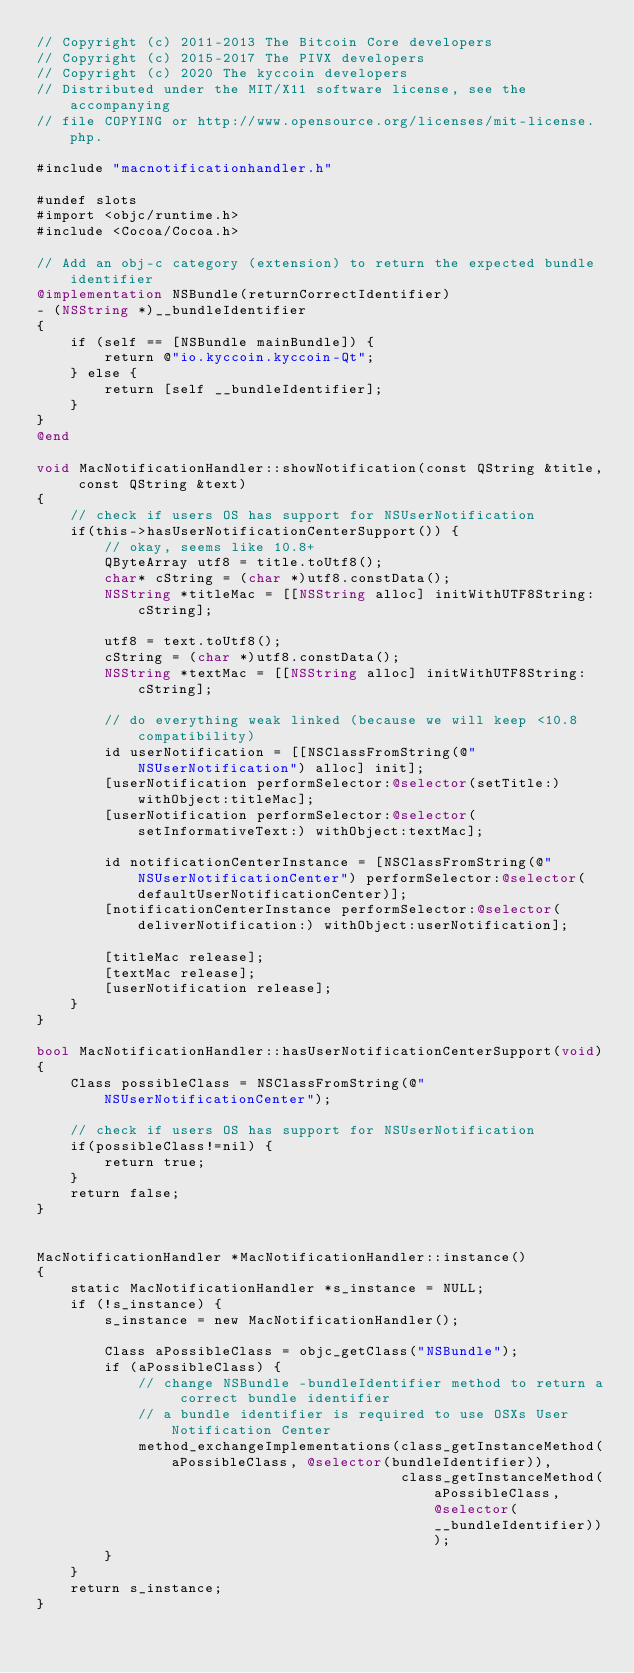Convert code to text. <code><loc_0><loc_0><loc_500><loc_500><_ObjectiveC_>// Copyright (c) 2011-2013 The Bitcoin Core developers
// Copyright (c) 2015-2017 The PIVX developers
// Copyright (c) 2020 The kyccoin developers
// Distributed under the MIT/X11 software license, see the accompanying
// file COPYING or http://www.opensource.org/licenses/mit-license.php.

#include "macnotificationhandler.h"

#undef slots
#import <objc/runtime.h>
#include <Cocoa/Cocoa.h>

// Add an obj-c category (extension) to return the expected bundle identifier
@implementation NSBundle(returnCorrectIdentifier)
- (NSString *)__bundleIdentifier
{
    if (self == [NSBundle mainBundle]) {
        return @"io.kyccoin.kyccoin-Qt";
    } else {
        return [self __bundleIdentifier];
    }
}
@end

void MacNotificationHandler::showNotification(const QString &title, const QString &text)
{
    // check if users OS has support for NSUserNotification
    if(this->hasUserNotificationCenterSupport()) {
        // okay, seems like 10.8+
        QByteArray utf8 = title.toUtf8();
        char* cString = (char *)utf8.constData();
        NSString *titleMac = [[NSString alloc] initWithUTF8String:cString];

        utf8 = text.toUtf8();
        cString = (char *)utf8.constData();
        NSString *textMac = [[NSString alloc] initWithUTF8String:cString];

        // do everything weak linked (because we will keep <10.8 compatibility)
        id userNotification = [[NSClassFromString(@"NSUserNotification") alloc] init];
        [userNotification performSelector:@selector(setTitle:) withObject:titleMac];
        [userNotification performSelector:@selector(setInformativeText:) withObject:textMac];

        id notificationCenterInstance = [NSClassFromString(@"NSUserNotificationCenter") performSelector:@selector(defaultUserNotificationCenter)];
        [notificationCenterInstance performSelector:@selector(deliverNotification:) withObject:userNotification];

        [titleMac release];
        [textMac release];
        [userNotification release];
    }
}

bool MacNotificationHandler::hasUserNotificationCenterSupport(void)
{
    Class possibleClass = NSClassFromString(@"NSUserNotificationCenter");

    // check if users OS has support for NSUserNotification
    if(possibleClass!=nil) {
        return true;
    }
    return false;
}


MacNotificationHandler *MacNotificationHandler::instance()
{
    static MacNotificationHandler *s_instance = NULL;
    if (!s_instance) {
        s_instance = new MacNotificationHandler();
        
        Class aPossibleClass = objc_getClass("NSBundle");
        if (aPossibleClass) {
            // change NSBundle -bundleIdentifier method to return a correct bundle identifier
            // a bundle identifier is required to use OSXs User Notification Center
            method_exchangeImplementations(class_getInstanceMethod(aPossibleClass, @selector(bundleIdentifier)),
                                           class_getInstanceMethod(aPossibleClass, @selector(__bundleIdentifier)));
        }
    }
    return s_instance;
}
</code> 